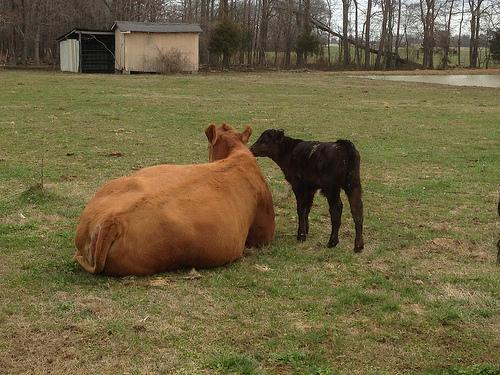Count the number of buildings or structures in the image. There are three structures in the image - a small brown building with a black roof, a small metal open shed coming off the small building, and a gray-roofed shed in the field. Describe the mood or atmosphere conveyed by this image. The image conveys a peaceful and calm atmosphere, with the cows enjoying their day in the sunshine. How many cows are in the image and what are their positions? There are two cows in the image - a brown mother cow lying on the ground and a black baby calf standing next to her. What is the setting of this image? The image is set on a farm, featuring a field of green and brown grass, with a row of trees in the background and two sheds across the field. Examine the field where the cows are and list any irregularities in the grass. The field consists of green and brown grass with patches of dirt, suggesting that the grass may be worn or not well-maintained. Provide a detailed description of the mother cow's ears. The mother cow's left ear is situated at coordinates (202, 122) with a width of 17 and a height of 17, while her right ear is at (238, 123) with a width of 16 and a height of 16. Identify the primary objects in the image and their colors. A brown mother cow laying in the grass, a black baby calf standing beside its mother, green and brown grass, and a small pond in the background. What are some distinguishing features of the two cows? The brown mother cow has a curled tail, and her ears are sticking up, while the black baby calf has a slightly visible head and stands upright. What is the significance of the small pond in the image? The small pond adds an element of tranquility to the image while also indicating that there might be a source of water for the cows. Explain an interaction happening between the two cows. The black calf is standing beside its mother, and it appears that the calf might be licking its mother. Notice the big, shiny tractor parked next to the cow and calf. There is no mention of a tractor in the given information. Including a tractor might imply a different setting or focus for the image. Where is the big red balloon floating above the small pond in the image? There is no mention of a balloon in the given information. It is also an unlikely object to appear in a rural farm scene with cows and a pond. Can you find a bright red, yellow, and blue parrot sitting on the cow's back? There is no mention of a parrot in the given information. Additionally, parrots are not commonly found on cows. Identify the large pink barn in the bottom-right corner of the image. There is no mention of any pink barn in the given information, and all other buildings in the image are described as small. Observe the group of picnicking people wearing colorful clothing in the background. This instruction is misleading because there is no mention of any people in the image, let alone a group of picnickers. Are there any other farm animals, such as horses or donkeys, visible in the image? This instruction is misleading because none of the provided details suggest the presence of other farm animals like horses or donkeys. 